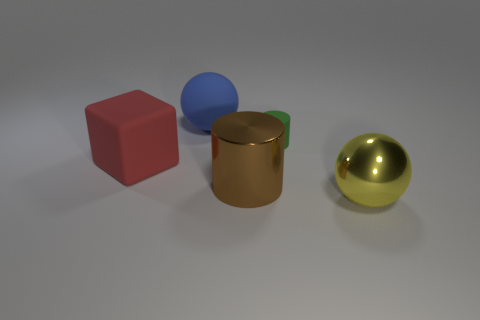Add 2 big gray rubber objects. How many objects exist? 7 Subtract all cylinders. How many objects are left? 3 Add 4 small brown objects. How many small brown objects exist? 4 Subtract 0 red balls. How many objects are left? 5 Subtract all big yellow metal spheres. Subtract all green things. How many objects are left? 3 Add 3 blue things. How many blue things are left? 4 